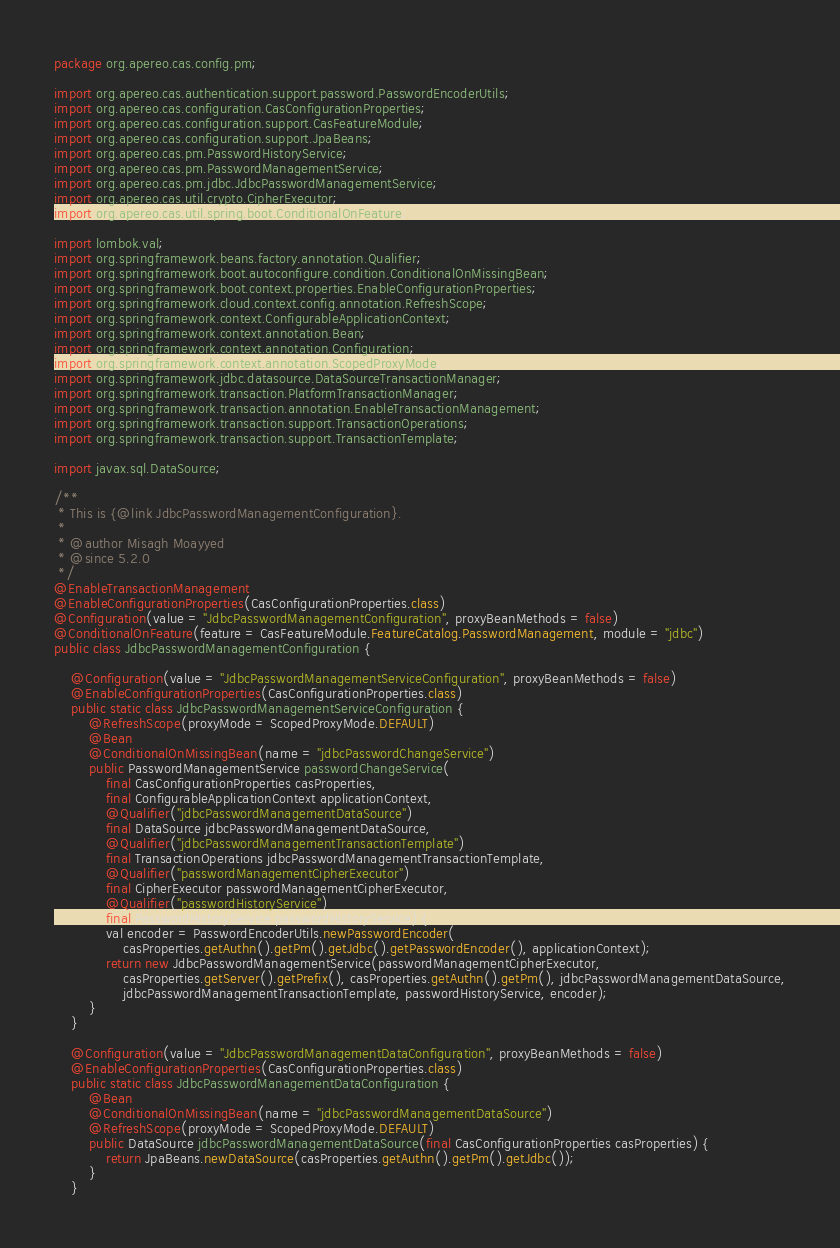<code> <loc_0><loc_0><loc_500><loc_500><_Java_>package org.apereo.cas.config.pm;

import org.apereo.cas.authentication.support.password.PasswordEncoderUtils;
import org.apereo.cas.configuration.CasConfigurationProperties;
import org.apereo.cas.configuration.support.CasFeatureModule;
import org.apereo.cas.configuration.support.JpaBeans;
import org.apereo.cas.pm.PasswordHistoryService;
import org.apereo.cas.pm.PasswordManagementService;
import org.apereo.cas.pm.jdbc.JdbcPasswordManagementService;
import org.apereo.cas.util.crypto.CipherExecutor;
import org.apereo.cas.util.spring.boot.ConditionalOnFeature;

import lombok.val;
import org.springframework.beans.factory.annotation.Qualifier;
import org.springframework.boot.autoconfigure.condition.ConditionalOnMissingBean;
import org.springframework.boot.context.properties.EnableConfigurationProperties;
import org.springframework.cloud.context.config.annotation.RefreshScope;
import org.springframework.context.ConfigurableApplicationContext;
import org.springframework.context.annotation.Bean;
import org.springframework.context.annotation.Configuration;
import org.springframework.context.annotation.ScopedProxyMode;
import org.springframework.jdbc.datasource.DataSourceTransactionManager;
import org.springframework.transaction.PlatformTransactionManager;
import org.springframework.transaction.annotation.EnableTransactionManagement;
import org.springframework.transaction.support.TransactionOperations;
import org.springframework.transaction.support.TransactionTemplate;

import javax.sql.DataSource;

/**
 * This is {@link JdbcPasswordManagementConfiguration}.
 *
 * @author Misagh Moayyed
 * @since 5.2.0
 */
@EnableTransactionManagement
@EnableConfigurationProperties(CasConfigurationProperties.class)
@Configuration(value = "JdbcPasswordManagementConfiguration", proxyBeanMethods = false)
@ConditionalOnFeature(feature = CasFeatureModule.FeatureCatalog.PasswordManagement, module = "jdbc")
public class JdbcPasswordManagementConfiguration {

    @Configuration(value = "JdbcPasswordManagementServiceConfiguration", proxyBeanMethods = false)
    @EnableConfigurationProperties(CasConfigurationProperties.class)
    public static class JdbcPasswordManagementServiceConfiguration {
        @RefreshScope(proxyMode = ScopedProxyMode.DEFAULT)
        @Bean
        @ConditionalOnMissingBean(name = "jdbcPasswordChangeService")
        public PasswordManagementService passwordChangeService(
            final CasConfigurationProperties casProperties,
            final ConfigurableApplicationContext applicationContext,
            @Qualifier("jdbcPasswordManagementDataSource")
            final DataSource jdbcPasswordManagementDataSource,
            @Qualifier("jdbcPasswordManagementTransactionTemplate")
            final TransactionOperations jdbcPasswordManagementTransactionTemplate,
            @Qualifier("passwordManagementCipherExecutor")
            final CipherExecutor passwordManagementCipherExecutor,
            @Qualifier("passwordHistoryService")
            final PasswordHistoryService passwordHistoryService) {
            val encoder = PasswordEncoderUtils.newPasswordEncoder(
                casProperties.getAuthn().getPm().getJdbc().getPasswordEncoder(), applicationContext);
            return new JdbcPasswordManagementService(passwordManagementCipherExecutor,
                casProperties.getServer().getPrefix(), casProperties.getAuthn().getPm(), jdbcPasswordManagementDataSource,
                jdbcPasswordManagementTransactionTemplate, passwordHistoryService, encoder);
        }
    }

    @Configuration(value = "JdbcPasswordManagementDataConfiguration", proxyBeanMethods = false)
    @EnableConfigurationProperties(CasConfigurationProperties.class)
    public static class JdbcPasswordManagementDataConfiguration {
        @Bean
        @ConditionalOnMissingBean(name = "jdbcPasswordManagementDataSource")
        @RefreshScope(proxyMode = ScopedProxyMode.DEFAULT)
        public DataSource jdbcPasswordManagementDataSource(final CasConfigurationProperties casProperties) {
            return JpaBeans.newDataSource(casProperties.getAuthn().getPm().getJdbc());
        }
    }
</code> 